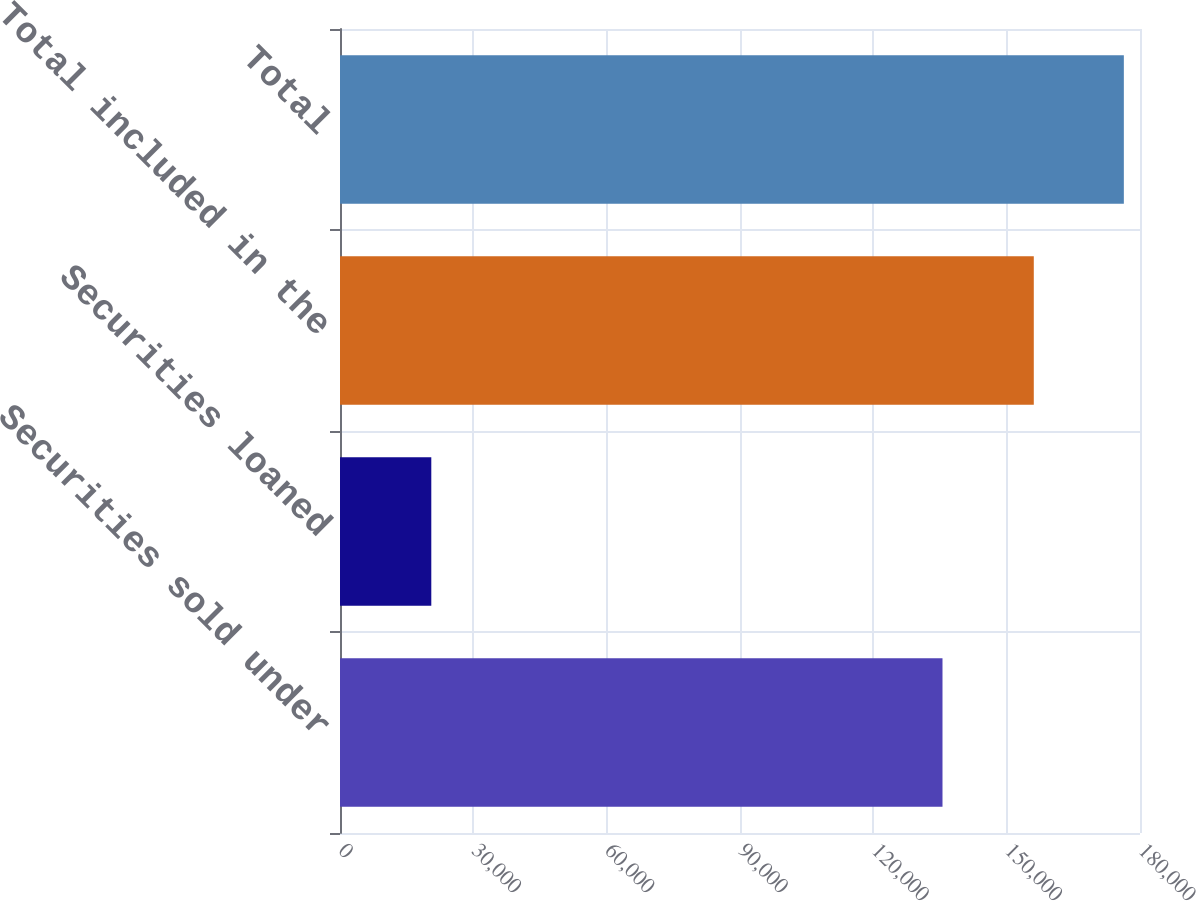Convert chart to OTSL. <chart><loc_0><loc_0><loc_500><loc_500><bar_chart><fcel>Securities sold under<fcel>Securities loaned<fcel>Total included in the<fcel>Total<nl><fcel>135561<fcel>20542<fcel>156103<fcel>176365<nl></chart> 